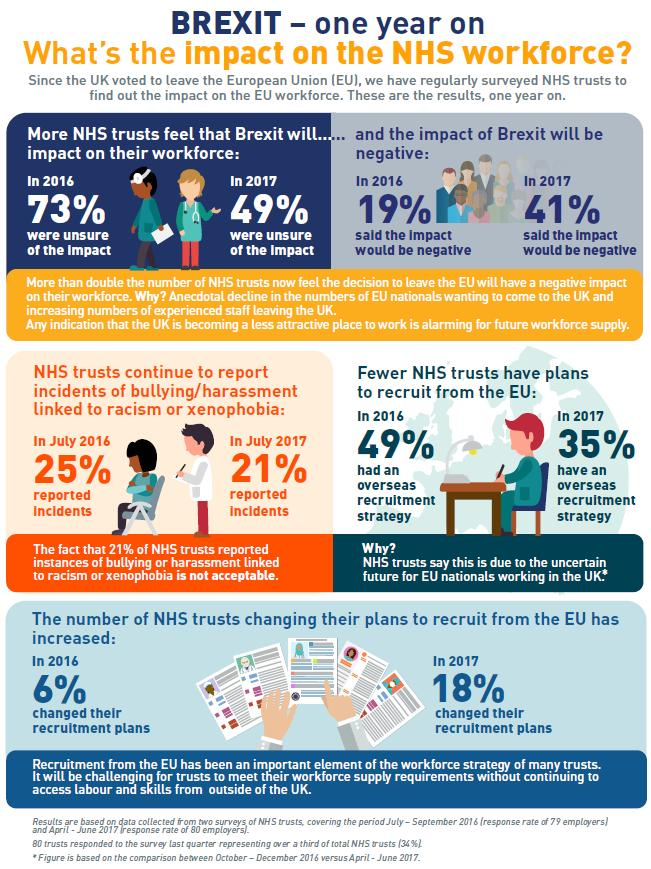Mention a couple of crucial points in this snapshot. According to the report, there has been a 12% increase in the number of NHS trusts changing their recruitment plans over the past year. In 2017, 18% of NHS trusts changed their recruitment plans as a response to the ongoing COVID-19 pandemic. The overseas recruitment strategy decreased by 14% when compared to 2016, representing a significant decline. The NHS trusts have declared that the reduction in their overseas recruitment strategy is due to the uncertain future for EU nationals working in the UK. In 2017, it was reported that 21% of racism-related harassments occurred. 